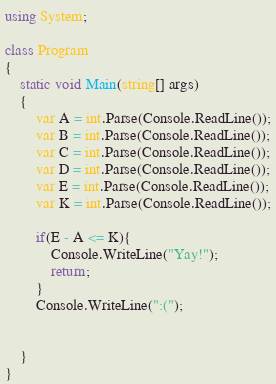Convert code to text. <code><loc_0><loc_0><loc_500><loc_500><_C#_>using System;

class Program
{
	static void Main(string[] args)
	{
		var A = int.Parse(Console.ReadLine());
		var B = int.Parse(Console.ReadLine());
		var C = int.Parse(Console.ReadLine());
		var D = int.Parse(Console.ReadLine());
		var E = int.Parse(Console.ReadLine());
		var K = int.Parse(Console.ReadLine());

		if(E - A <= K){
			Console.WriteLine("Yay!");
			return;
		}
		Console.WriteLine(":(");
		
    
	}
}</code> 